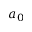<formula> <loc_0><loc_0><loc_500><loc_500>a _ { 0 }</formula> 